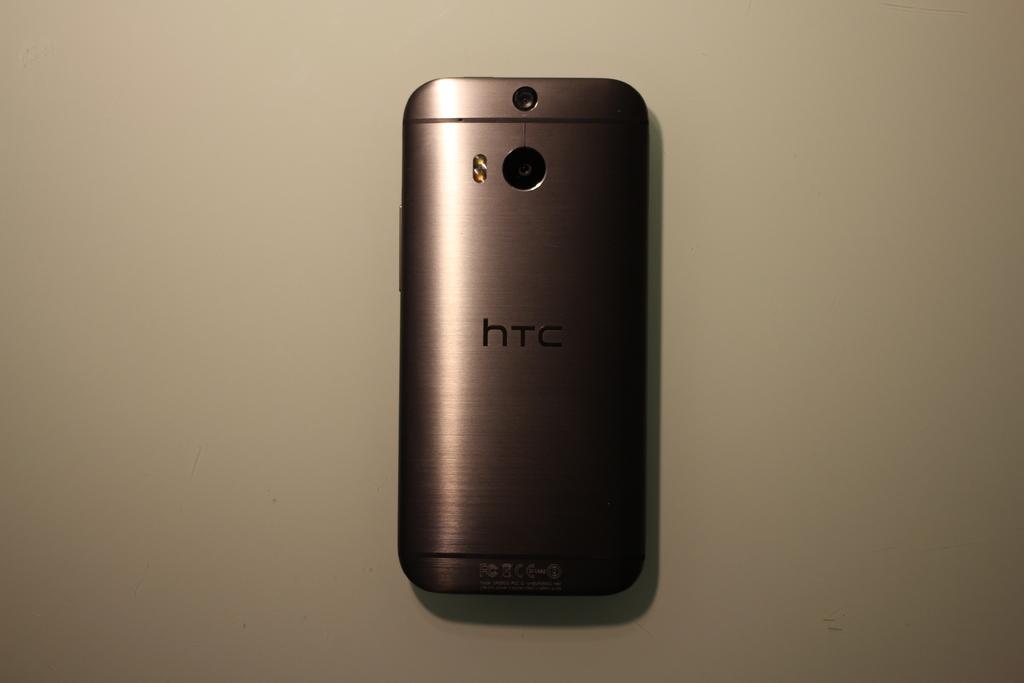What product is being advertised?
Offer a terse response. Htc. 